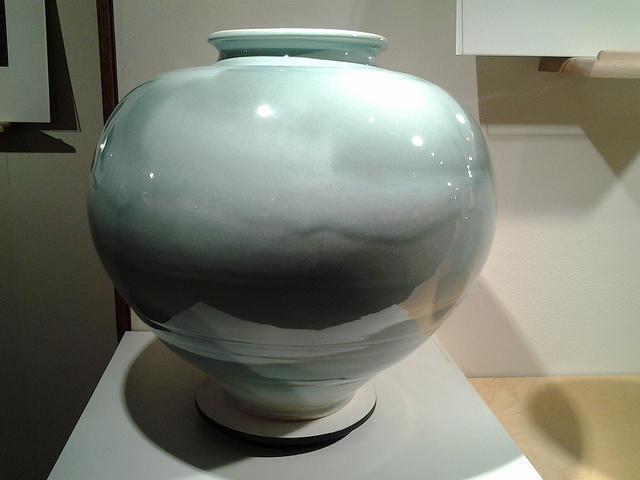How many colors are on the vase?
Give a very brief answer. 1. How many buses are there?
Give a very brief answer. 0. 